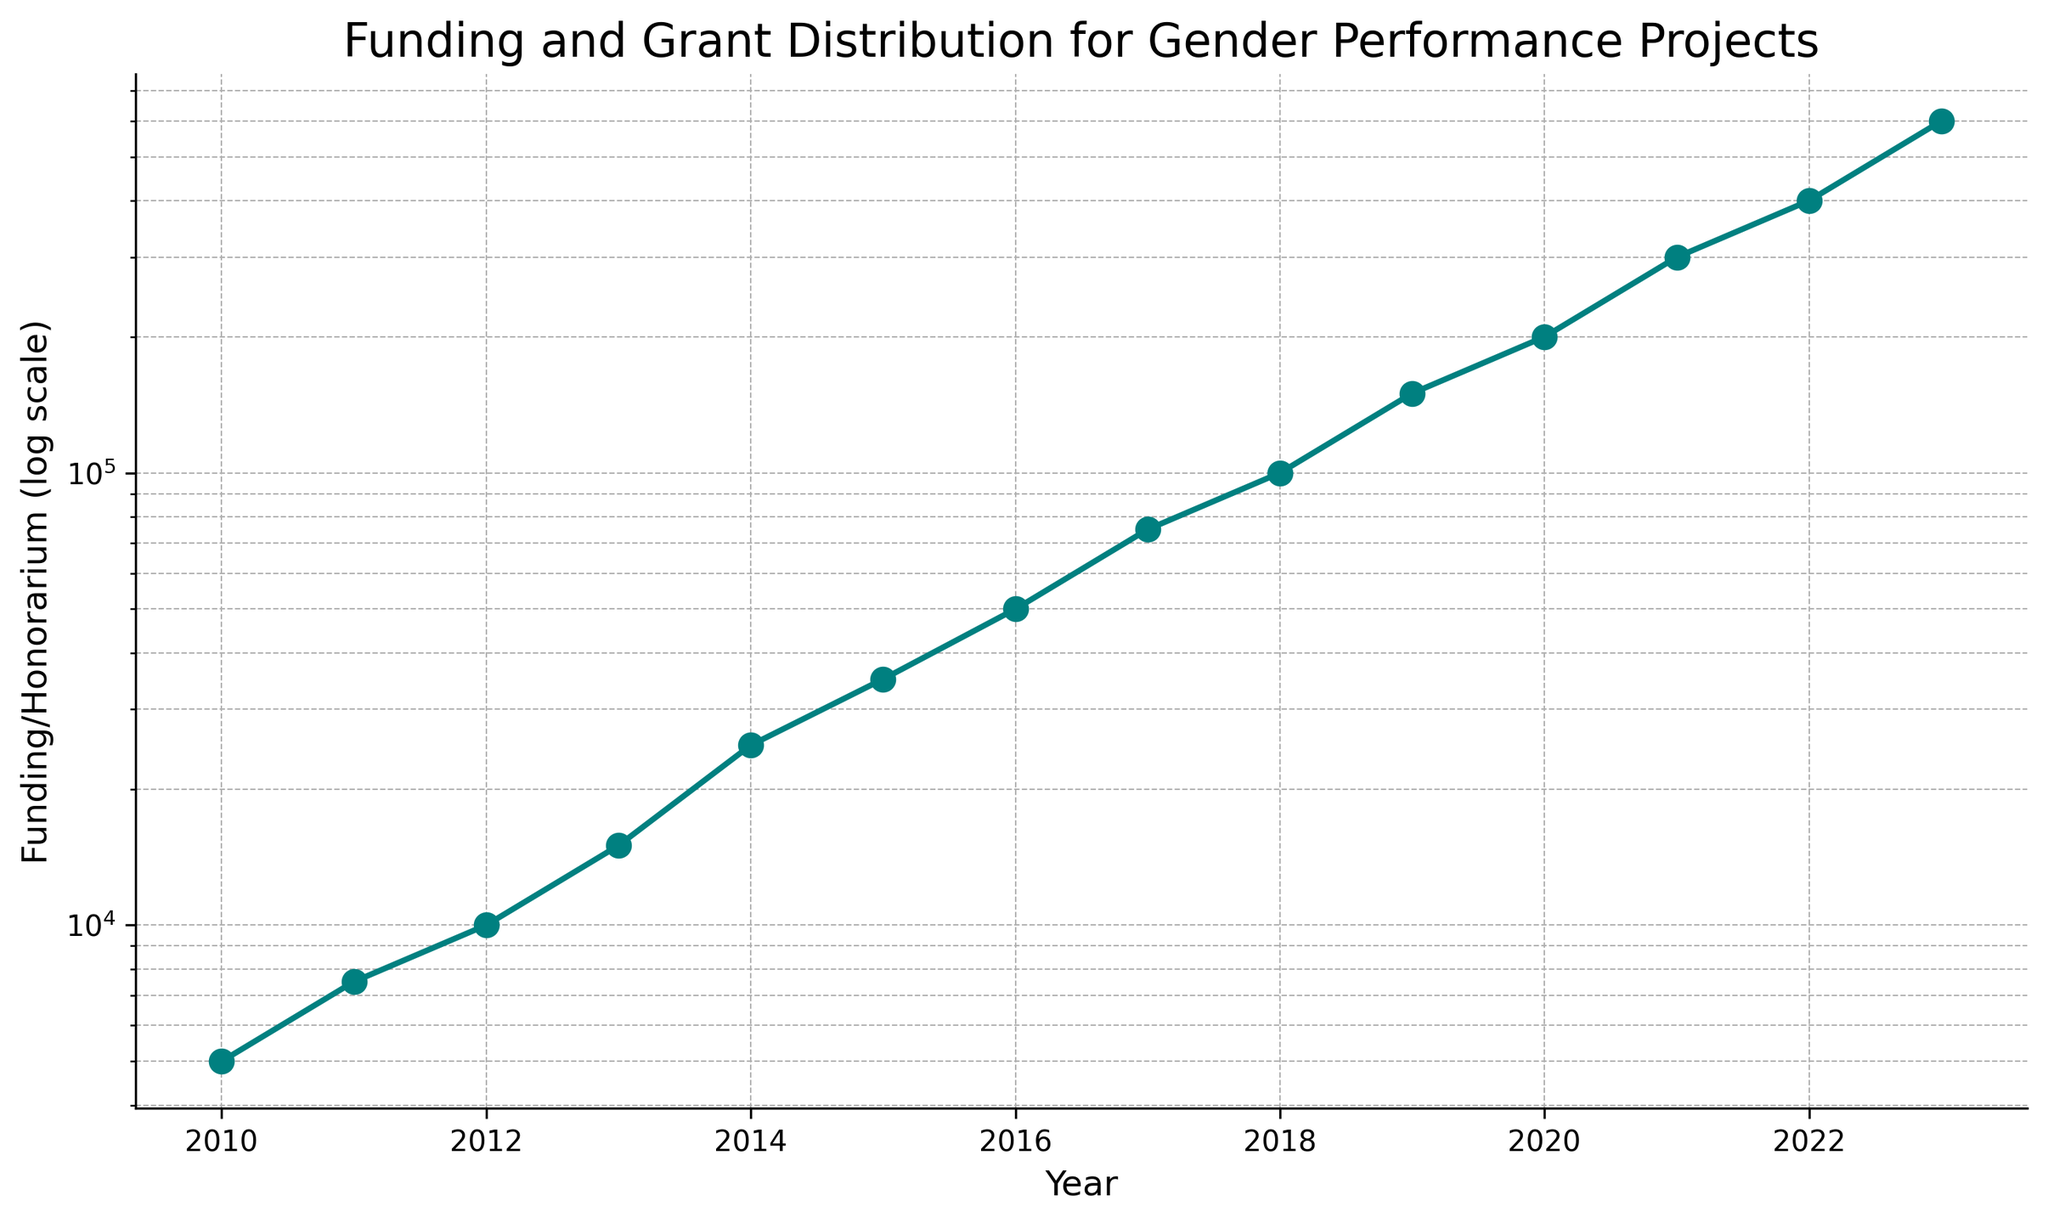What is the overall trend in funding from 2010 to 2023? The funding amount consistently increases from 2010 to 2023. This trend can be observed as a steady upward trajectory in the plotted data points on the logscale chart.
Answer: Increasing How does the funding amount in 2023 compare to the funding amount in 2010? In 2010, the funding amount is 5000, while in 2023, it is 600000. By comparing these data points, we see that the funding in 2023 is significantly higher than in 2010.
Answer: Much higher During which year did the funding surpass 100,000? By observing the plotted data points on the logscale, we can see that the funding surpasses 100,000 in 2018.
Answer: 2018 What is the ratio of funding in 2023 to the funding in 2010? The funding in 2023 is 600,000 and in 2010 it is 5,000. The ratio is calculated as 600,000 / 5,000.
Answer: 120 Between which consecutive years did the largest increase in funding occur? By examining the steepest ascent on the logscale chart, the largest increase occurs between 2022 and 2023. The funding rises from 400,000 to 600,000.
Answer: Between 2022 and 2023 What is the median funding amount from 2010 to 2023? Listing the funding values in order: 5000, 7500, 10000, 15000, 25000, 35000, 50000, 75000, 100000, 150000, 200000, 300000, 400000, 600000. The median value is the average of the middle two values (50,000 and 75,000), which is 62500.
Answer: 62500 How did the rate of funding increase change after 2016 compared to before? Before 2016, the funding grew from 5,000 to 50,000. After 2016, it grew from 50,000 to 600,000. The rate of increase accelerates significantly after 2016.
Answer: Accelerates Is there any year where no change in funding is evident from the previous year? By reviewing the plotted data points, there is no year where the funding remains the same from one year to the next; all years show some increase.
Answer: No What proportion of the total funding over the years does the year 2023 contribute alone? Total funding = sum of all yearly fundings: 5,000 + 7,500 + 10,000 + 15,000 + 25,000 + 35,000 + 50,000 + 75,000 + 100,000 + 150,000 + 200,000 + 300,000 + 400,000 + 600,000 = 1,972,500. The proportion contributed by 2023 is 600,000 / 1,972,500.
Answer: Approximately 0.304 or 30.4% Which years saw at least a 50% increase in funding compared to the previous year? The years with at least a 50% increase can be identified by comparing the funding amounts year over year. Significant increases are seen between 2010 and 2011, 2013 and 2014, 2014 and 2015, 2015 and 2016, 2016 and 2017, 2017 and 2018, 2018 and 2019, 2019 and 2020, 2020 and 2021, 2021 and 2022, and 2022 and 2023.
Answer: Most years after 2010 